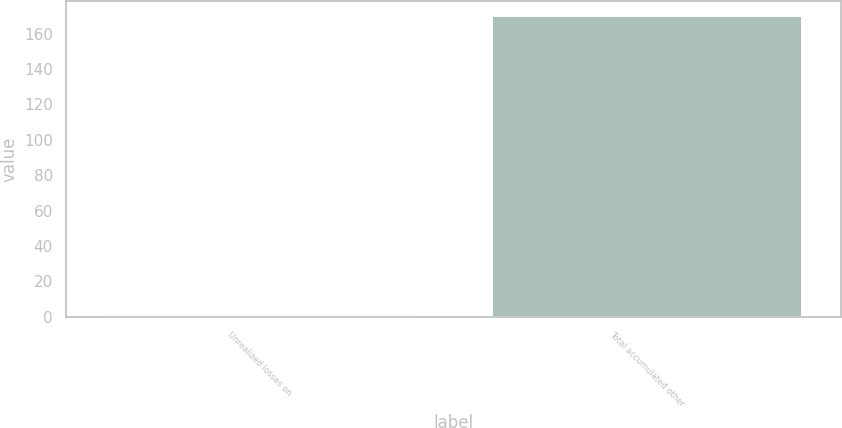Convert chart to OTSL. <chart><loc_0><loc_0><loc_500><loc_500><bar_chart><fcel>Unrealized losses on<fcel>Total accumulated other<nl><fcel>1<fcel>170<nl></chart> 